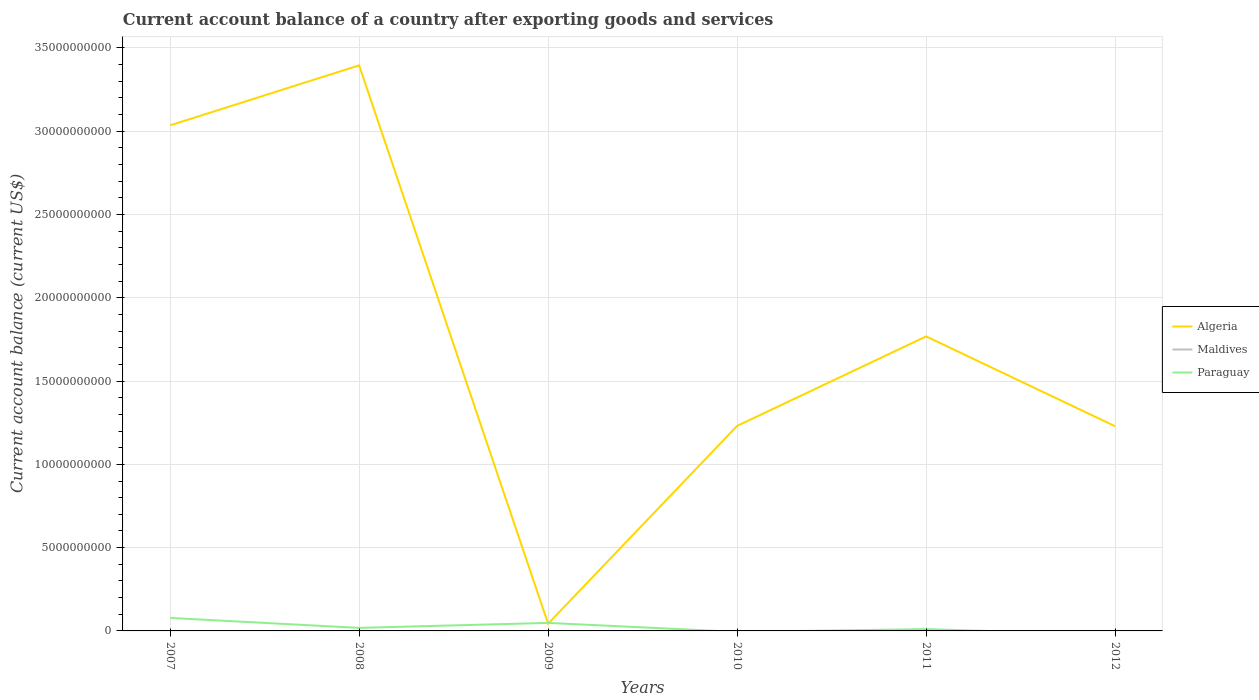How many different coloured lines are there?
Your response must be concise. 2. Is the number of lines equal to the number of legend labels?
Provide a short and direct response. No. What is the total account balance in Algeria in the graph?
Provide a succinct answer. 3.35e+1. What is the difference between the highest and the second highest account balance in Algeria?
Offer a very short reply. 3.35e+1. How many lines are there?
Provide a succinct answer. 2. What is the difference between two consecutive major ticks on the Y-axis?
Offer a very short reply. 5.00e+09. Does the graph contain any zero values?
Offer a terse response. Yes. What is the title of the graph?
Your answer should be compact. Current account balance of a country after exporting goods and services. Does "Somalia" appear as one of the legend labels in the graph?
Provide a short and direct response. No. What is the label or title of the Y-axis?
Your response must be concise. Current account balance (current US$). What is the Current account balance (current US$) in Algeria in 2007?
Make the answer very short. 3.04e+1. What is the Current account balance (current US$) of Paraguay in 2007?
Offer a very short reply. 7.79e+08. What is the Current account balance (current US$) of Algeria in 2008?
Your answer should be compact. 3.40e+1. What is the Current account balance (current US$) of Paraguay in 2008?
Offer a terse response. 1.83e+08. What is the Current account balance (current US$) in Algeria in 2009?
Offer a terse response. 4.34e+08. What is the Current account balance (current US$) of Maldives in 2009?
Offer a very short reply. 0. What is the Current account balance (current US$) of Paraguay in 2009?
Offer a very short reply. 4.82e+08. What is the Current account balance (current US$) of Algeria in 2010?
Your answer should be very brief. 1.23e+1. What is the Current account balance (current US$) of Paraguay in 2010?
Ensure brevity in your answer.  0. What is the Current account balance (current US$) in Algeria in 2011?
Provide a succinct answer. 1.77e+1. What is the Current account balance (current US$) of Paraguay in 2011?
Offer a terse response. 1.09e+08. What is the Current account balance (current US$) of Algeria in 2012?
Provide a succinct answer. 1.23e+1. What is the Current account balance (current US$) in Maldives in 2012?
Keep it short and to the point. 0. What is the Current account balance (current US$) of Paraguay in 2012?
Your response must be concise. 0. Across all years, what is the maximum Current account balance (current US$) of Algeria?
Offer a very short reply. 3.40e+1. Across all years, what is the maximum Current account balance (current US$) in Paraguay?
Provide a succinct answer. 7.79e+08. Across all years, what is the minimum Current account balance (current US$) in Algeria?
Keep it short and to the point. 4.34e+08. What is the total Current account balance (current US$) of Algeria in the graph?
Make the answer very short. 1.07e+11. What is the total Current account balance (current US$) in Maldives in the graph?
Offer a very short reply. 0. What is the total Current account balance (current US$) in Paraguay in the graph?
Your response must be concise. 1.55e+09. What is the difference between the Current account balance (current US$) of Algeria in 2007 and that in 2008?
Keep it short and to the point. -3.60e+09. What is the difference between the Current account balance (current US$) in Paraguay in 2007 and that in 2008?
Make the answer very short. 5.96e+08. What is the difference between the Current account balance (current US$) of Algeria in 2007 and that in 2009?
Provide a succinct answer. 2.99e+1. What is the difference between the Current account balance (current US$) of Paraguay in 2007 and that in 2009?
Ensure brevity in your answer.  2.97e+08. What is the difference between the Current account balance (current US$) in Algeria in 2007 and that in 2010?
Make the answer very short. 1.80e+1. What is the difference between the Current account balance (current US$) in Algeria in 2007 and that in 2011?
Make the answer very short. 1.27e+1. What is the difference between the Current account balance (current US$) in Paraguay in 2007 and that in 2011?
Your response must be concise. 6.70e+08. What is the difference between the Current account balance (current US$) of Algeria in 2007 and that in 2012?
Give a very brief answer. 1.81e+1. What is the difference between the Current account balance (current US$) of Algeria in 2008 and that in 2009?
Offer a terse response. 3.35e+1. What is the difference between the Current account balance (current US$) in Paraguay in 2008 and that in 2009?
Make the answer very short. -2.98e+08. What is the difference between the Current account balance (current US$) of Algeria in 2008 and that in 2010?
Your response must be concise. 2.16e+1. What is the difference between the Current account balance (current US$) of Algeria in 2008 and that in 2011?
Offer a very short reply. 1.63e+1. What is the difference between the Current account balance (current US$) in Paraguay in 2008 and that in 2011?
Your answer should be compact. 7.42e+07. What is the difference between the Current account balance (current US$) of Algeria in 2008 and that in 2012?
Ensure brevity in your answer.  2.17e+1. What is the difference between the Current account balance (current US$) in Algeria in 2009 and that in 2010?
Provide a succinct answer. -1.19e+1. What is the difference between the Current account balance (current US$) in Algeria in 2009 and that in 2011?
Give a very brief answer. -1.72e+1. What is the difference between the Current account balance (current US$) of Paraguay in 2009 and that in 2011?
Your response must be concise. 3.73e+08. What is the difference between the Current account balance (current US$) in Algeria in 2009 and that in 2012?
Your response must be concise. -1.19e+1. What is the difference between the Current account balance (current US$) of Algeria in 2010 and that in 2011?
Provide a short and direct response. -5.37e+09. What is the difference between the Current account balance (current US$) in Algeria in 2010 and that in 2012?
Keep it short and to the point. 1.95e+07. What is the difference between the Current account balance (current US$) of Algeria in 2011 and that in 2012?
Ensure brevity in your answer.  5.39e+09. What is the difference between the Current account balance (current US$) in Algeria in 2007 and the Current account balance (current US$) in Paraguay in 2008?
Your response must be concise. 3.02e+1. What is the difference between the Current account balance (current US$) in Algeria in 2007 and the Current account balance (current US$) in Paraguay in 2009?
Your response must be concise. 2.99e+1. What is the difference between the Current account balance (current US$) of Algeria in 2007 and the Current account balance (current US$) of Paraguay in 2011?
Your answer should be very brief. 3.02e+1. What is the difference between the Current account balance (current US$) in Algeria in 2008 and the Current account balance (current US$) in Paraguay in 2009?
Ensure brevity in your answer.  3.35e+1. What is the difference between the Current account balance (current US$) of Algeria in 2008 and the Current account balance (current US$) of Paraguay in 2011?
Your answer should be very brief. 3.38e+1. What is the difference between the Current account balance (current US$) in Algeria in 2009 and the Current account balance (current US$) in Paraguay in 2011?
Make the answer very short. 3.25e+08. What is the difference between the Current account balance (current US$) in Algeria in 2010 and the Current account balance (current US$) in Paraguay in 2011?
Keep it short and to the point. 1.22e+1. What is the average Current account balance (current US$) in Algeria per year?
Ensure brevity in your answer.  1.78e+1. What is the average Current account balance (current US$) of Maldives per year?
Offer a terse response. 0. What is the average Current account balance (current US$) in Paraguay per year?
Provide a short and direct response. 2.59e+08. In the year 2007, what is the difference between the Current account balance (current US$) of Algeria and Current account balance (current US$) of Paraguay?
Your answer should be very brief. 2.96e+1. In the year 2008, what is the difference between the Current account balance (current US$) in Algeria and Current account balance (current US$) in Paraguay?
Provide a succinct answer. 3.38e+1. In the year 2009, what is the difference between the Current account balance (current US$) of Algeria and Current account balance (current US$) of Paraguay?
Make the answer very short. -4.75e+07. In the year 2011, what is the difference between the Current account balance (current US$) of Algeria and Current account balance (current US$) of Paraguay?
Keep it short and to the point. 1.76e+1. What is the ratio of the Current account balance (current US$) of Algeria in 2007 to that in 2008?
Your answer should be very brief. 0.89. What is the ratio of the Current account balance (current US$) of Paraguay in 2007 to that in 2008?
Offer a very short reply. 4.25. What is the ratio of the Current account balance (current US$) of Algeria in 2007 to that in 2009?
Ensure brevity in your answer.  69.94. What is the ratio of the Current account balance (current US$) in Paraguay in 2007 to that in 2009?
Your response must be concise. 1.62. What is the ratio of the Current account balance (current US$) in Algeria in 2007 to that in 2010?
Offer a terse response. 2.47. What is the ratio of the Current account balance (current US$) in Algeria in 2007 to that in 2011?
Provide a succinct answer. 1.72. What is the ratio of the Current account balance (current US$) in Paraguay in 2007 to that in 2011?
Ensure brevity in your answer.  7.15. What is the ratio of the Current account balance (current US$) of Algeria in 2007 to that in 2012?
Provide a succinct answer. 2.47. What is the ratio of the Current account balance (current US$) of Algeria in 2008 to that in 2009?
Ensure brevity in your answer.  78.24. What is the ratio of the Current account balance (current US$) in Paraguay in 2008 to that in 2009?
Your answer should be very brief. 0.38. What is the ratio of the Current account balance (current US$) in Algeria in 2008 to that in 2010?
Offer a very short reply. 2.76. What is the ratio of the Current account balance (current US$) in Algeria in 2008 to that in 2011?
Your answer should be compact. 1.92. What is the ratio of the Current account balance (current US$) in Paraguay in 2008 to that in 2011?
Your answer should be compact. 1.68. What is the ratio of the Current account balance (current US$) in Algeria in 2008 to that in 2012?
Your response must be concise. 2.76. What is the ratio of the Current account balance (current US$) in Algeria in 2009 to that in 2010?
Provide a succinct answer. 0.04. What is the ratio of the Current account balance (current US$) of Algeria in 2009 to that in 2011?
Give a very brief answer. 0.02. What is the ratio of the Current account balance (current US$) of Paraguay in 2009 to that in 2011?
Your answer should be compact. 4.42. What is the ratio of the Current account balance (current US$) in Algeria in 2009 to that in 2012?
Offer a very short reply. 0.04. What is the ratio of the Current account balance (current US$) of Algeria in 2010 to that in 2011?
Keep it short and to the point. 0.7. What is the ratio of the Current account balance (current US$) of Algeria in 2010 to that in 2012?
Your answer should be very brief. 1. What is the ratio of the Current account balance (current US$) of Algeria in 2011 to that in 2012?
Offer a terse response. 1.44. What is the difference between the highest and the second highest Current account balance (current US$) of Algeria?
Provide a short and direct response. 3.60e+09. What is the difference between the highest and the second highest Current account balance (current US$) of Paraguay?
Offer a very short reply. 2.97e+08. What is the difference between the highest and the lowest Current account balance (current US$) in Algeria?
Your answer should be very brief. 3.35e+1. What is the difference between the highest and the lowest Current account balance (current US$) in Paraguay?
Provide a short and direct response. 7.79e+08. 